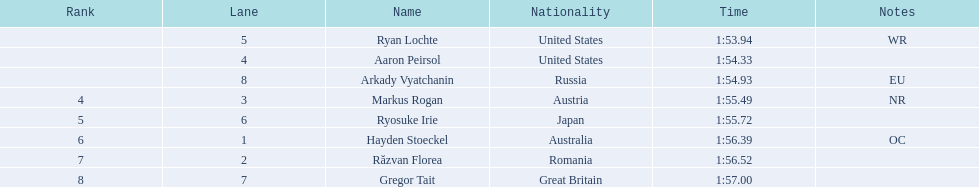Who are the individuals participating in swimming? Ryan Lochte, Aaron Peirsol, Arkady Vyatchanin, Markus Rogan, Ryosuke Irie, Hayden Stoeckel, Răzvan Florea, Gregor Tait. What is the duration of ryosuke irie's performance? 1:55.72. 